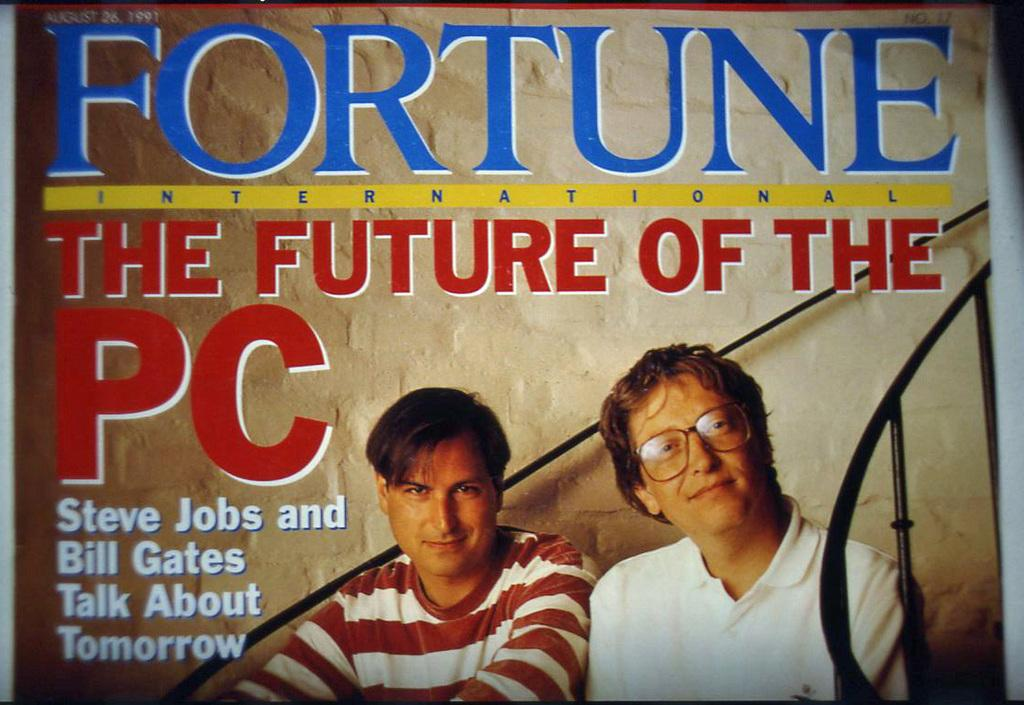What is featured on the poster in the image? There is a poster in the image that contains words, numbers, and an image of two persons. Can you describe the content of the poster in more detail? The poster contains words and numbers, and there is an image of two persons on it. What type of lettuce is being used as a horn by one of the persons on the poster? There is no lettuce or horn present in the image; the poster contains words, numbers, and an image of two persons. 